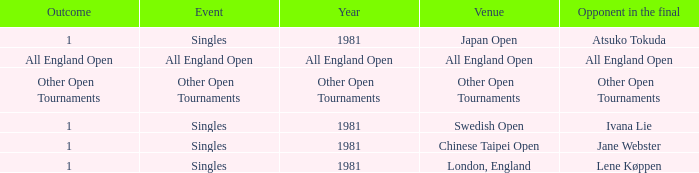Who was the Opponent in London, England with an Outcome of 1? Lene Køppen. 